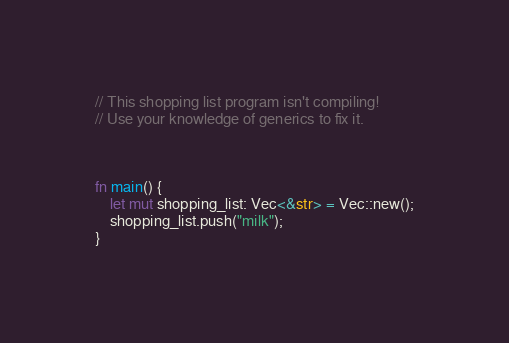<code> <loc_0><loc_0><loc_500><loc_500><_Rust_>// This shopping list program isn't compiling! 
// Use your knowledge of generics to fix it.



fn main() {
    let mut shopping_list: Vec<&str> = Vec::new();
    shopping_list.push("milk");
}

</code> 